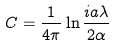<formula> <loc_0><loc_0><loc_500><loc_500>C = \frac { 1 } { 4 \pi } \ln \frac { i a \lambda } { 2 \alpha }</formula> 